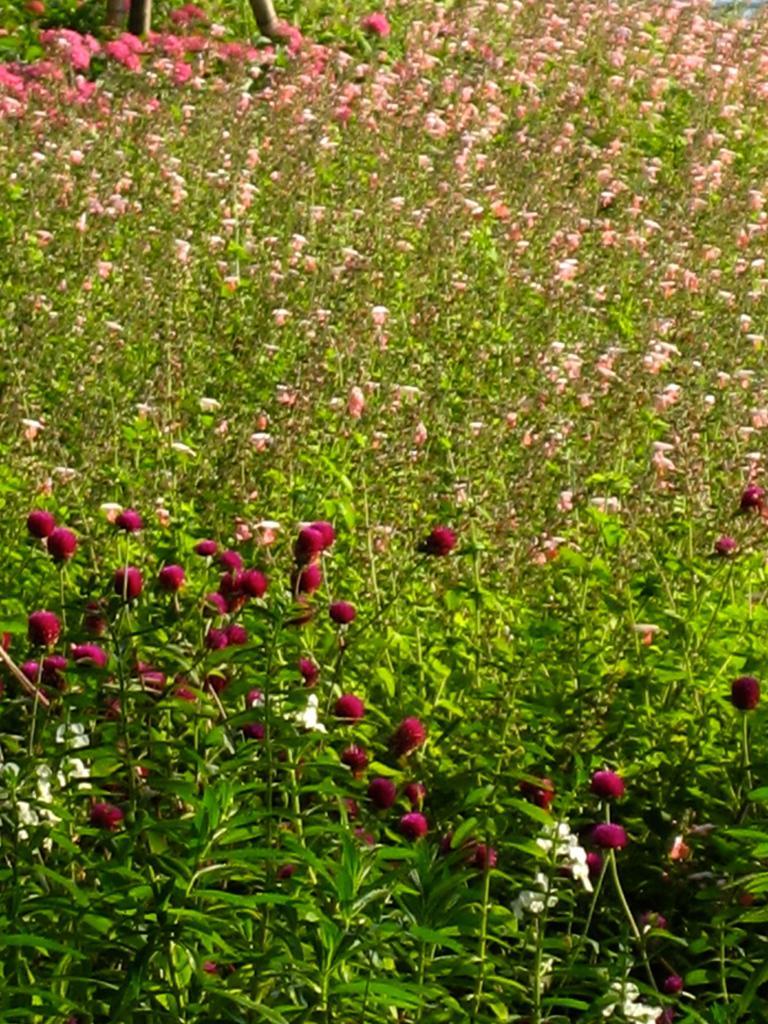Describe this image in one or two sentences. This image is consists of flowers field. 